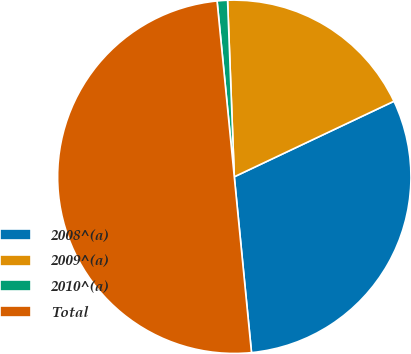Convert chart. <chart><loc_0><loc_0><loc_500><loc_500><pie_chart><fcel>2008^(a)<fcel>2009^(a)<fcel>2010^(a)<fcel>Total<nl><fcel>30.48%<fcel>18.57%<fcel>0.95%<fcel>50.0%<nl></chart> 